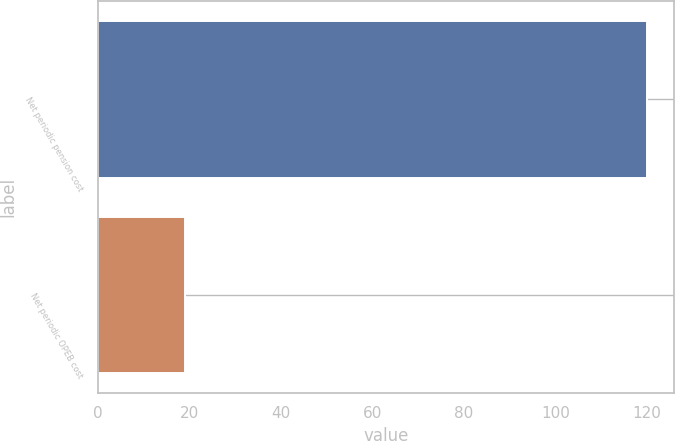Convert chart. <chart><loc_0><loc_0><loc_500><loc_500><bar_chart><fcel>Net periodic pension cost<fcel>Net periodic OPEB cost<nl><fcel>120<fcel>19<nl></chart> 